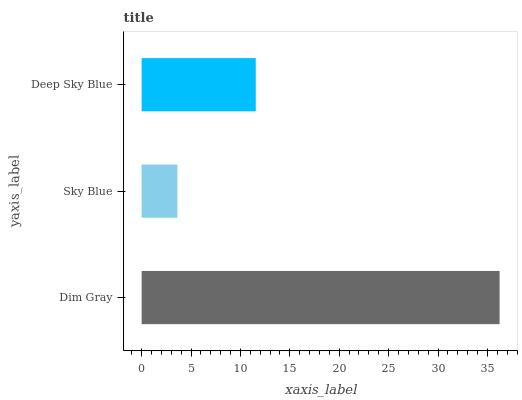Is Sky Blue the minimum?
Answer yes or no. Yes. Is Dim Gray the maximum?
Answer yes or no. Yes. Is Deep Sky Blue the minimum?
Answer yes or no. No. Is Deep Sky Blue the maximum?
Answer yes or no. No. Is Deep Sky Blue greater than Sky Blue?
Answer yes or no. Yes. Is Sky Blue less than Deep Sky Blue?
Answer yes or no. Yes. Is Sky Blue greater than Deep Sky Blue?
Answer yes or no. No. Is Deep Sky Blue less than Sky Blue?
Answer yes or no. No. Is Deep Sky Blue the high median?
Answer yes or no. Yes. Is Deep Sky Blue the low median?
Answer yes or no. Yes. Is Sky Blue the high median?
Answer yes or no. No. Is Dim Gray the low median?
Answer yes or no. No. 